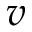<formula> <loc_0><loc_0><loc_500><loc_500>v</formula> 